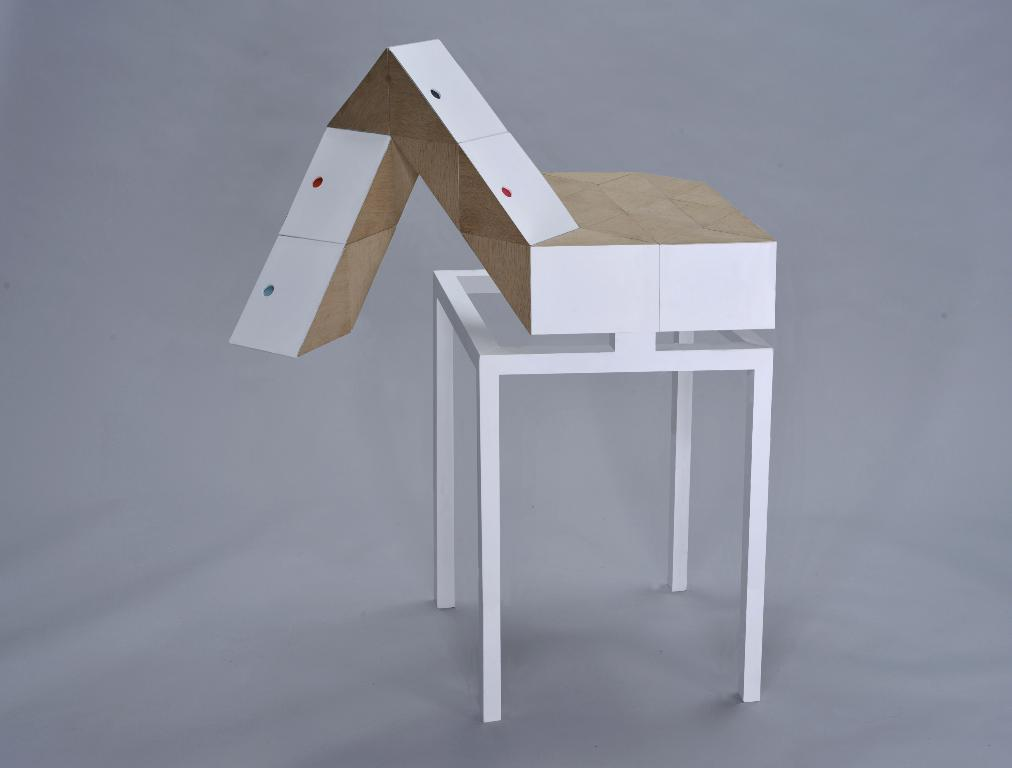What is the main object in the image? There is a table stand in the image. What is placed on the table stand? There is a wooden structure design block on the table stand. What type of railway is visible in the image? There is no railway present in the image. How many copies of the wooden structure design block are there in the image? There is only one wooden structure design block present in the image. 